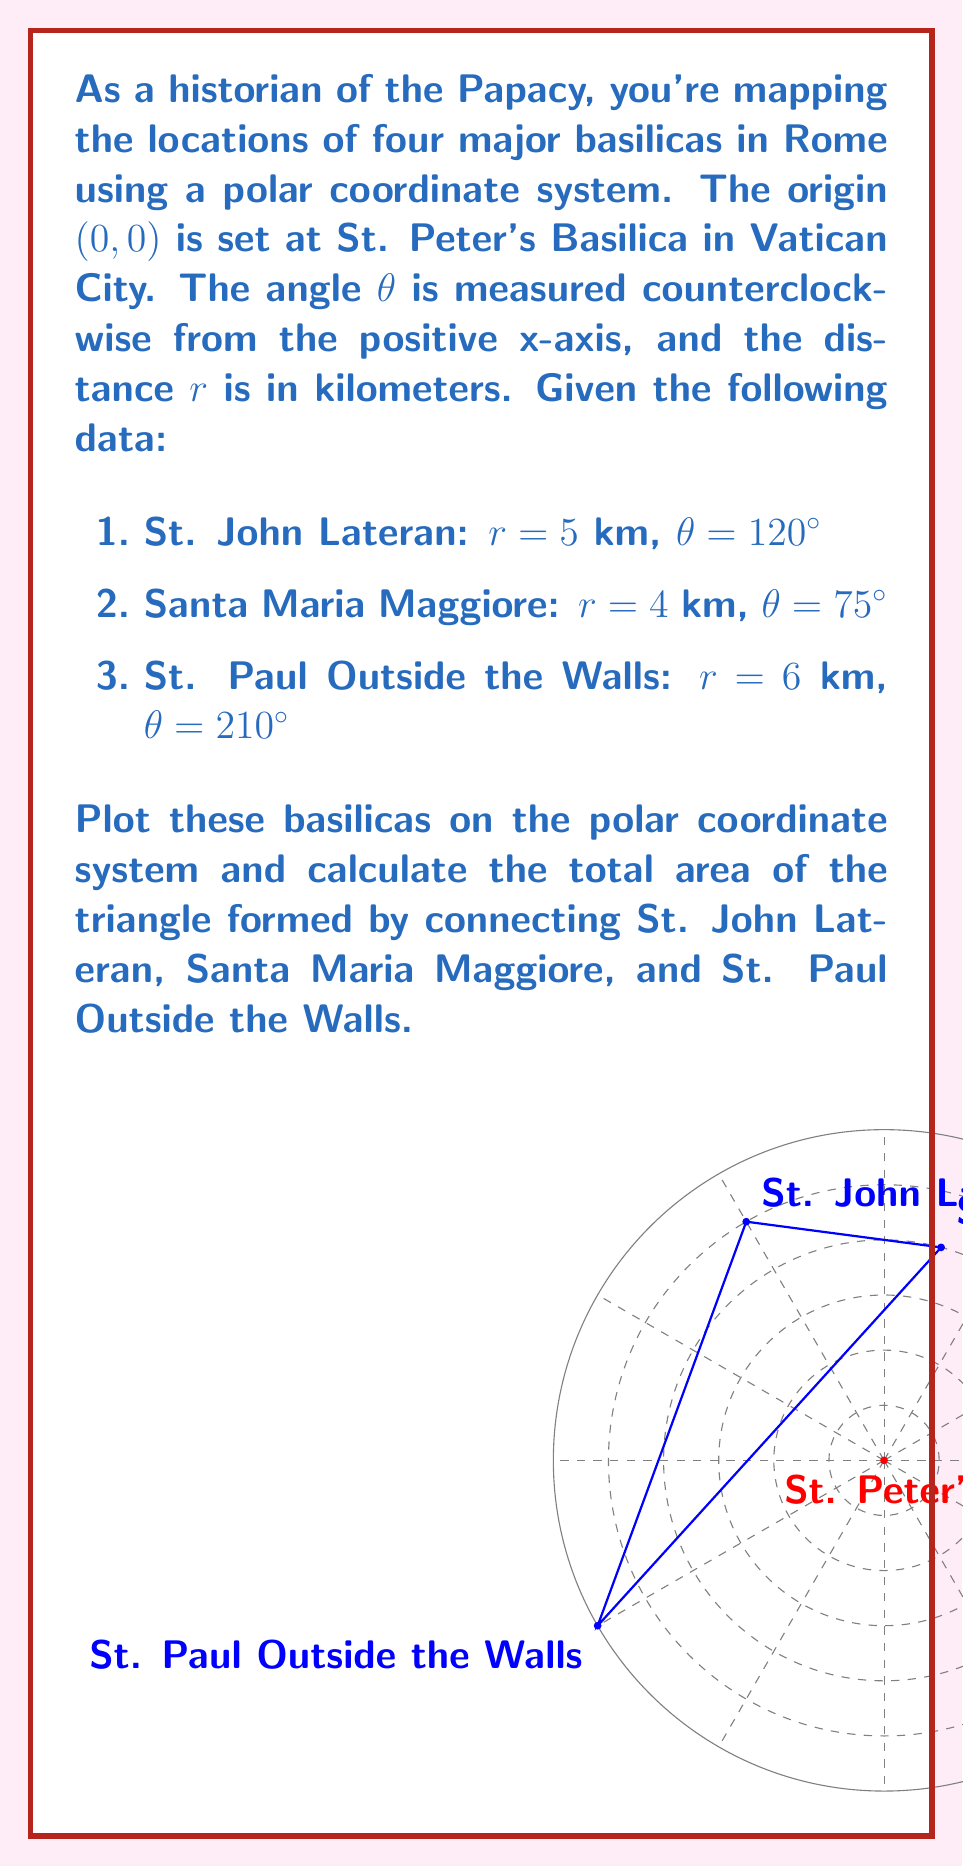Provide a solution to this math problem. To solve this problem, we'll follow these steps:

1) First, we need to convert the polar coordinates to Cartesian coordinates for each basilica:

   For point (r, θ), x = r * cos(θ) and y = r * sin(θ)

   St. John Lateran (A): 
   $x_A = 5 \cos(120°) = -2.5$ km
   $y_A = 5 \sin(120°) = 4.33$ km

   Santa Maria Maggiore (B):
   $x_B = 4 \cos(75°) = 1.04$ km
   $y_B = 4 \sin(75°) = 3.86$ km

   St. Paul Outside the Walls (C):
   $x_C = 6 \cos(210°) = -5.20$ km
   $y_C = 6 \sin(210°) = -3$ km

2) Now that we have the Cartesian coordinates, we can use the formula for the area of a triangle given three points:

   Area = $\frac{1}{2}|x_A(y_B - y_C) + x_B(y_C - y_A) + x_C(y_A - y_B)|$

3) Substituting our values:

   Area = $\frac{1}{2}|(-2.5)(3.86 - (-3)) + (1.04)((-3) - 4.33) + (-5.20)(4.33 - 3.86)|$

4) Simplifying:

   Area = $\frac{1}{2}|(-2.5)(6.86) + (1.04)(-7.33) + (-5.20)(0.47)|$
        = $\frac{1}{2}|-17.15 - 7.62 - 2.44|$
        = $\frac{1}{2}|-27.21|$
        = $13.605$ km²

Therefore, the area of the triangle formed by the three basilicas is approximately 13.605 square kilometers.
Answer: 13.605 km² 